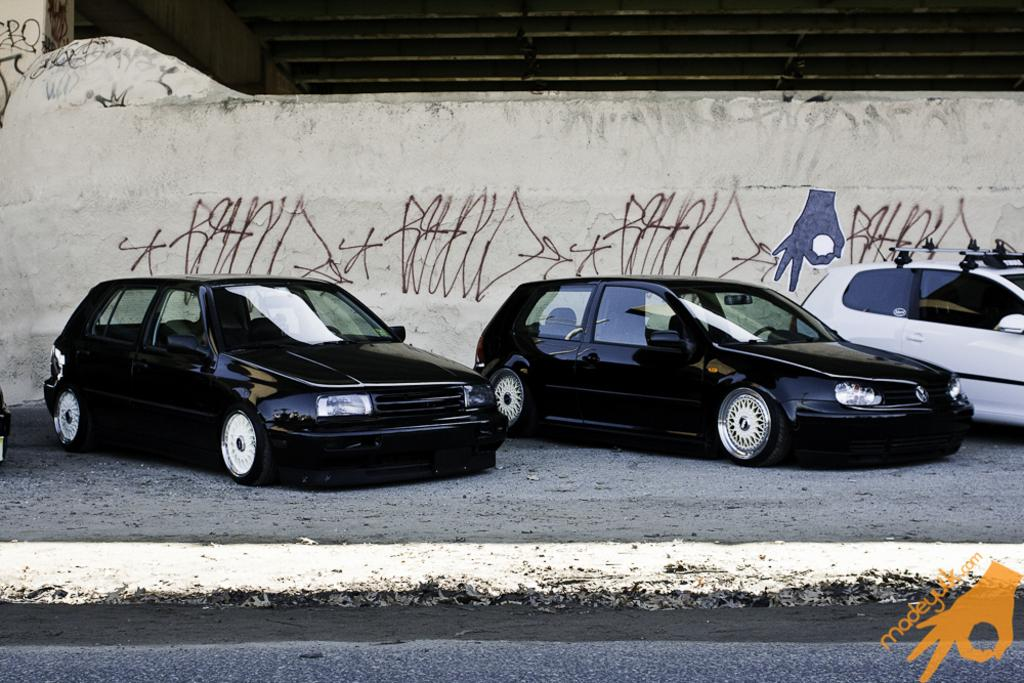How many cars can be seen in the image? There are three cars in the image. Where are the cars located in the image? The cars are parked on the side. What else is visible in the image besides the cars? There is a wall visible in the image. Is there any text or image on the wall? Yes, something is written on the wall. Can you see a kite flying in the image? No, there is no kite visible in the image. Is there a coil of wire on the wall in the image? No, there is no coil of wire mentioned in the image. 